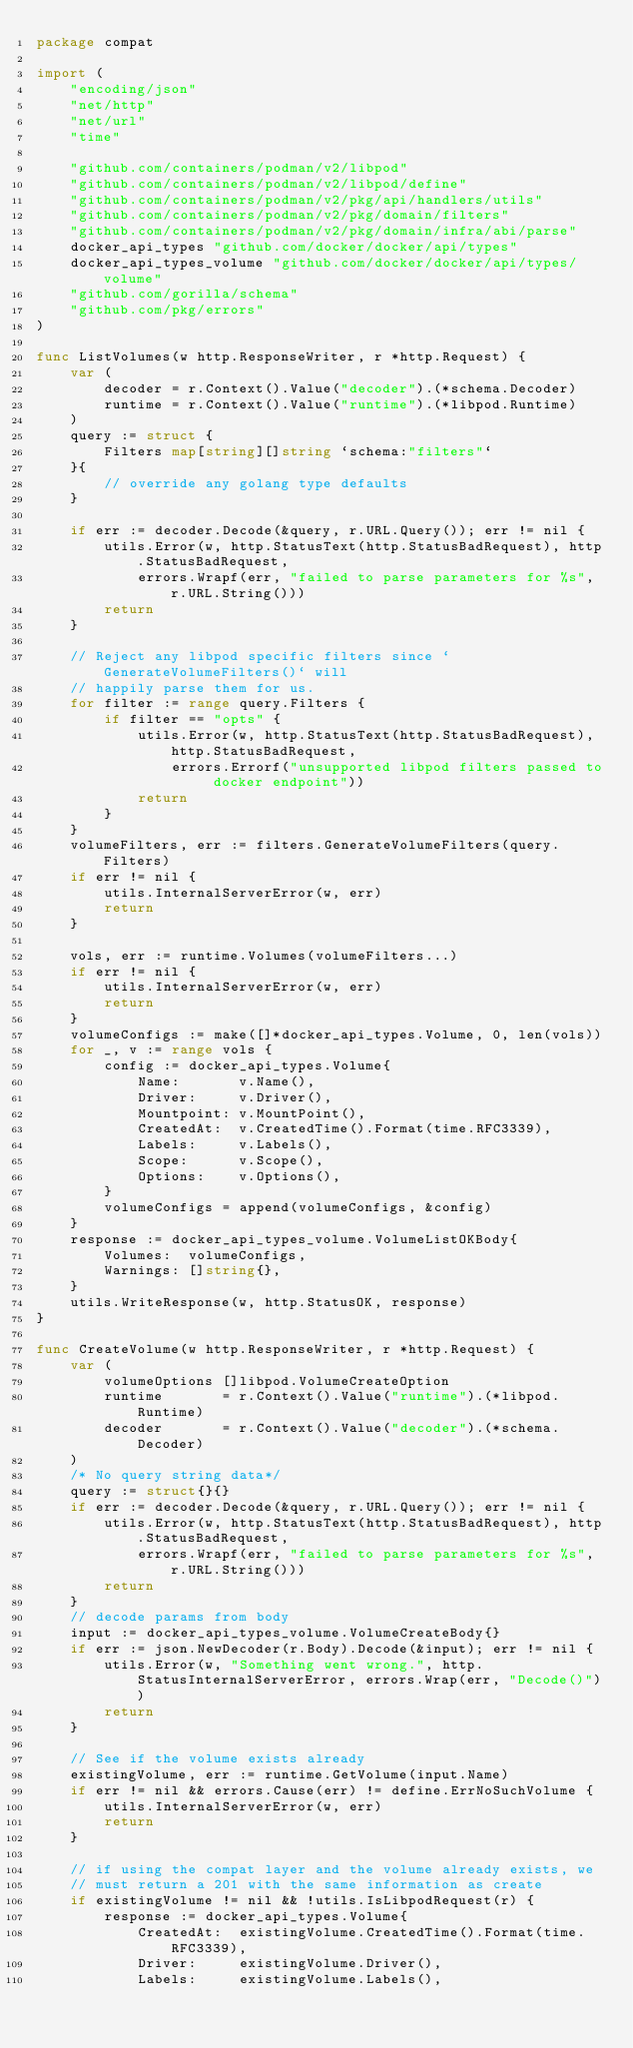Convert code to text. <code><loc_0><loc_0><loc_500><loc_500><_Go_>package compat

import (
	"encoding/json"
	"net/http"
	"net/url"
	"time"

	"github.com/containers/podman/v2/libpod"
	"github.com/containers/podman/v2/libpod/define"
	"github.com/containers/podman/v2/pkg/api/handlers/utils"
	"github.com/containers/podman/v2/pkg/domain/filters"
	"github.com/containers/podman/v2/pkg/domain/infra/abi/parse"
	docker_api_types "github.com/docker/docker/api/types"
	docker_api_types_volume "github.com/docker/docker/api/types/volume"
	"github.com/gorilla/schema"
	"github.com/pkg/errors"
)

func ListVolumes(w http.ResponseWriter, r *http.Request) {
	var (
		decoder = r.Context().Value("decoder").(*schema.Decoder)
		runtime = r.Context().Value("runtime").(*libpod.Runtime)
	)
	query := struct {
		Filters map[string][]string `schema:"filters"`
	}{
		// override any golang type defaults
	}

	if err := decoder.Decode(&query, r.URL.Query()); err != nil {
		utils.Error(w, http.StatusText(http.StatusBadRequest), http.StatusBadRequest,
			errors.Wrapf(err, "failed to parse parameters for %s", r.URL.String()))
		return
	}

	// Reject any libpod specific filters since `GenerateVolumeFilters()` will
	// happily parse them for us.
	for filter := range query.Filters {
		if filter == "opts" {
			utils.Error(w, http.StatusText(http.StatusBadRequest), http.StatusBadRequest,
				errors.Errorf("unsupported libpod filters passed to docker endpoint"))
			return
		}
	}
	volumeFilters, err := filters.GenerateVolumeFilters(query.Filters)
	if err != nil {
		utils.InternalServerError(w, err)
		return
	}

	vols, err := runtime.Volumes(volumeFilters...)
	if err != nil {
		utils.InternalServerError(w, err)
		return
	}
	volumeConfigs := make([]*docker_api_types.Volume, 0, len(vols))
	for _, v := range vols {
		config := docker_api_types.Volume{
			Name:       v.Name(),
			Driver:     v.Driver(),
			Mountpoint: v.MountPoint(),
			CreatedAt:  v.CreatedTime().Format(time.RFC3339),
			Labels:     v.Labels(),
			Scope:      v.Scope(),
			Options:    v.Options(),
		}
		volumeConfigs = append(volumeConfigs, &config)
	}
	response := docker_api_types_volume.VolumeListOKBody{
		Volumes:  volumeConfigs,
		Warnings: []string{},
	}
	utils.WriteResponse(w, http.StatusOK, response)
}

func CreateVolume(w http.ResponseWriter, r *http.Request) {
	var (
		volumeOptions []libpod.VolumeCreateOption
		runtime       = r.Context().Value("runtime").(*libpod.Runtime)
		decoder       = r.Context().Value("decoder").(*schema.Decoder)
	)
	/* No query string data*/
	query := struct{}{}
	if err := decoder.Decode(&query, r.URL.Query()); err != nil {
		utils.Error(w, http.StatusText(http.StatusBadRequest), http.StatusBadRequest,
			errors.Wrapf(err, "failed to parse parameters for %s", r.URL.String()))
		return
	}
	// decode params from body
	input := docker_api_types_volume.VolumeCreateBody{}
	if err := json.NewDecoder(r.Body).Decode(&input); err != nil {
		utils.Error(w, "Something went wrong.", http.StatusInternalServerError, errors.Wrap(err, "Decode()"))
		return
	}

	// See if the volume exists already
	existingVolume, err := runtime.GetVolume(input.Name)
	if err != nil && errors.Cause(err) != define.ErrNoSuchVolume {
		utils.InternalServerError(w, err)
		return
	}

	// if using the compat layer and the volume already exists, we
	// must return a 201 with the same information as create
	if existingVolume != nil && !utils.IsLibpodRequest(r) {
		response := docker_api_types.Volume{
			CreatedAt:  existingVolume.CreatedTime().Format(time.RFC3339),
			Driver:     existingVolume.Driver(),
			Labels:     existingVolume.Labels(),</code> 